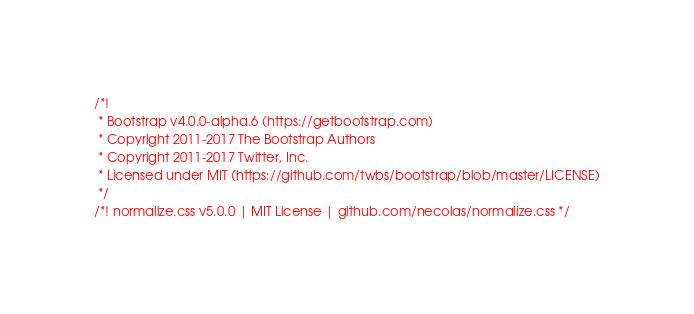Convert code to text. <code><loc_0><loc_0><loc_500><loc_500><_CSS_>/*!
 * Bootstrap v4.0.0-alpha.6 (https://getbootstrap.com)
 * Copyright 2011-2017 The Bootstrap Authors
 * Copyright 2011-2017 Twitter, Inc.
 * Licensed under MIT (https://github.com/twbs/bootstrap/blob/master/LICENSE)
 */
/*! normalize.css v5.0.0 | MIT License | github.com/necolas/normalize.css */</code> 